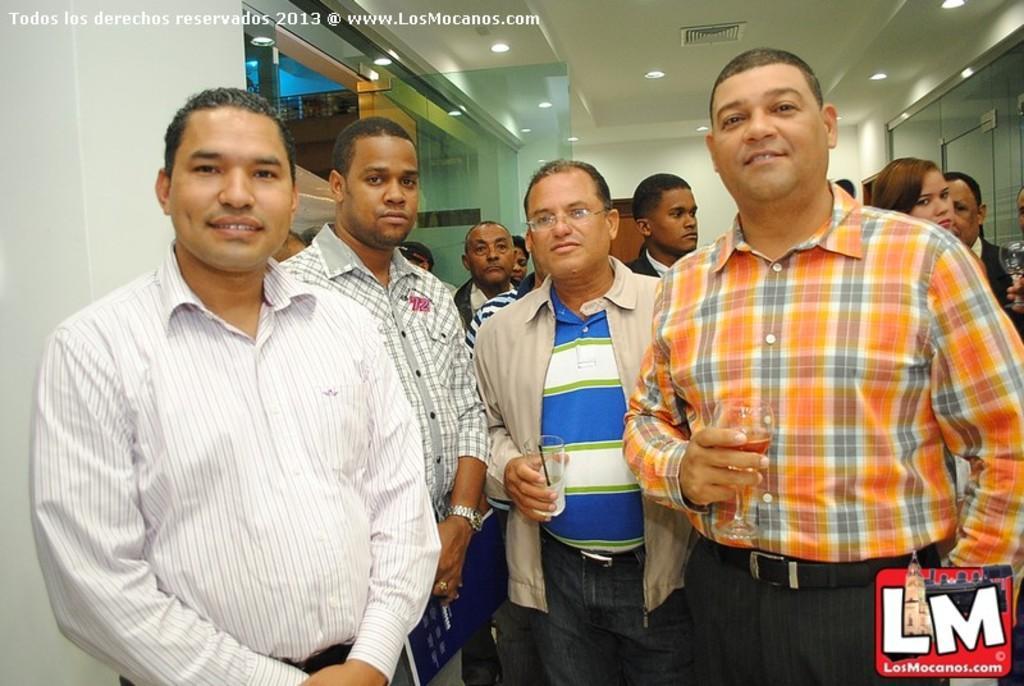In one or two sentences, can you explain what this image depicts? In this picture we can see group of people and few people holding glasses, in the background we can see few lights, in the top left hand corner we can find some text and we can see a logo in the bottom right hand corner. 